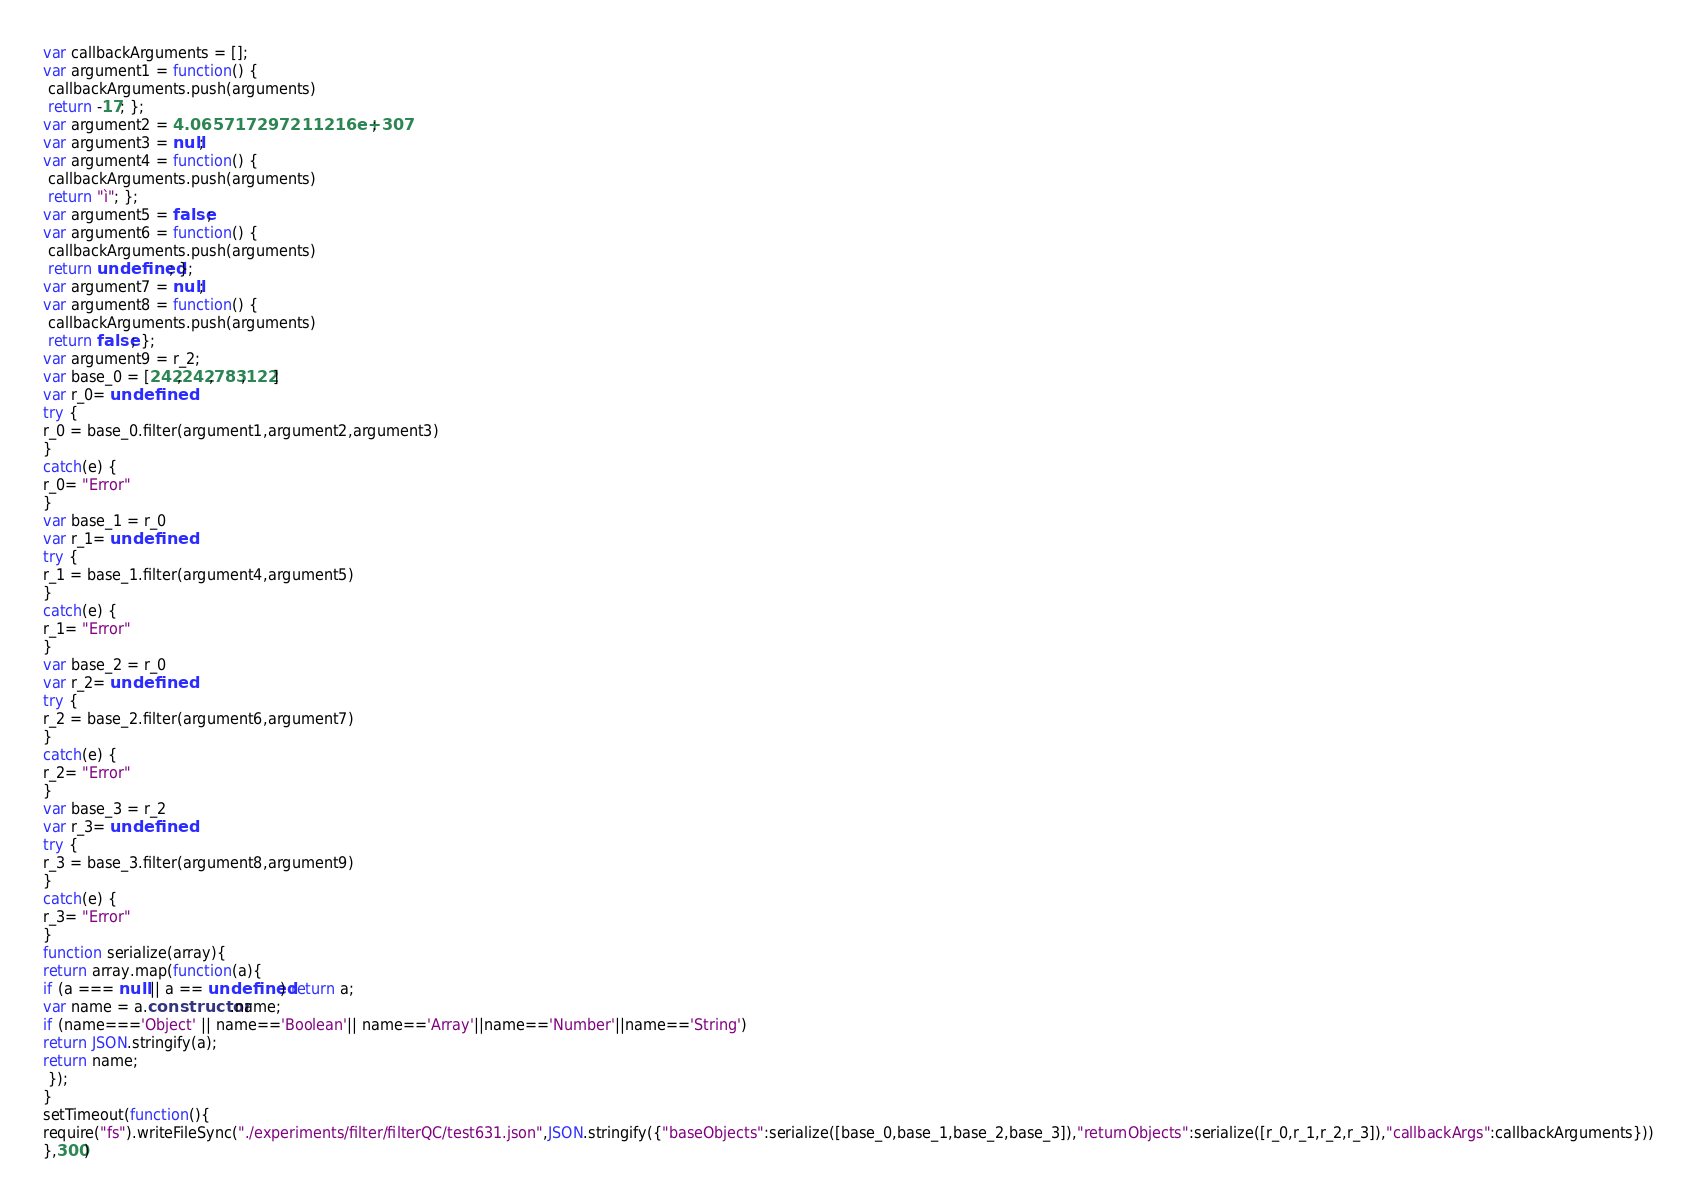<code> <loc_0><loc_0><loc_500><loc_500><_JavaScript_>





var callbackArguments = [];
var argument1 = function() {
 callbackArguments.push(arguments) 
 return -17; };
var argument2 = 4.065717297211216e+307;
var argument3 = null;
var argument4 = function() {
 callbackArguments.push(arguments) 
 return "ì"; };
var argument5 = false;
var argument6 = function() {
 callbackArguments.push(arguments) 
 return undefined; };
var argument7 = null;
var argument8 = function() {
 callbackArguments.push(arguments) 
 return false; };
var argument9 = r_2;
var base_0 = [242,242,783,122]
var r_0= undefined
try {
r_0 = base_0.filter(argument1,argument2,argument3)
}
catch(e) {
r_0= "Error"
}
var base_1 = r_0
var r_1= undefined
try {
r_1 = base_1.filter(argument4,argument5)
}
catch(e) {
r_1= "Error"
}
var base_2 = r_0
var r_2= undefined
try {
r_2 = base_2.filter(argument6,argument7)
}
catch(e) {
r_2= "Error"
}
var base_3 = r_2
var r_3= undefined
try {
r_3 = base_3.filter(argument8,argument9)
}
catch(e) {
r_3= "Error"
}
function serialize(array){
return array.map(function(a){
if (a === null || a == undefined) return a;
var name = a.constructor.name;
if (name==='Object' || name=='Boolean'|| name=='Array'||name=='Number'||name=='String')
return JSON.stringify(a);
return name;
 });
}
setTimeout(function(){
require("fs").writeFileSync("./experiments/filter/filterQC/test631.json",JSON.stringify({"baseObjects":serialize([base_0,base_1,base_2,base_3]),"returnObjects":serialize([r_0,r_1,r_2,r_3]),"callbackArgs":callbackArguments}))
},300)</code> 